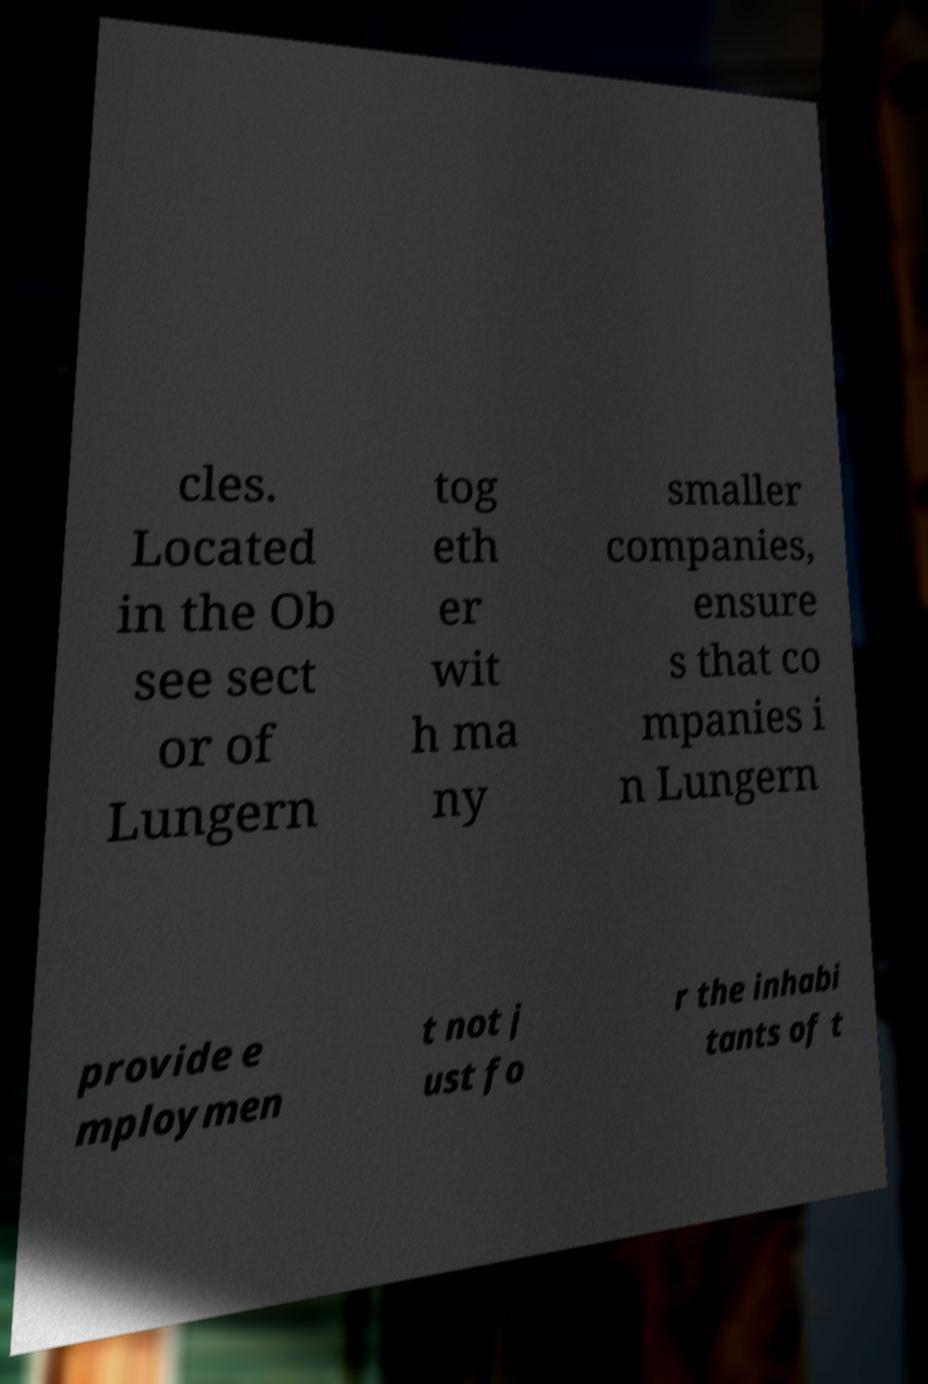Can you read and provide the text displayed in the image?This photo seems to have some interesting text. Can you extract and type it out for me? cles. Located in the Ob see sect or of Lungern tog eth er wit h ma ny smaller companies, ensure s that co mpanies i n Lungern provide e mploymen t not j ust fo r the inhabi tants of t 